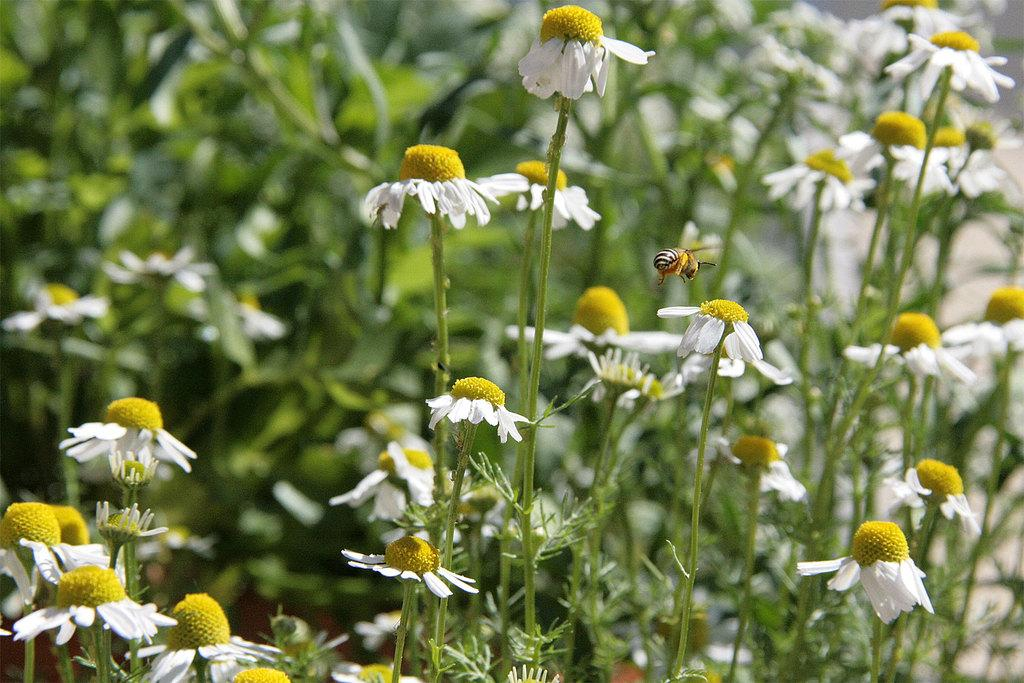What type of living organisms can be seen in the image? There are flowers and an insect in the image. What is the insect doing in the image? The insect is flying in the air in the image. How would you describe the background of the image? The background of the image is blurry. Can you see an airplane flying over the island in the image? There is no airplane or island present in the image. 